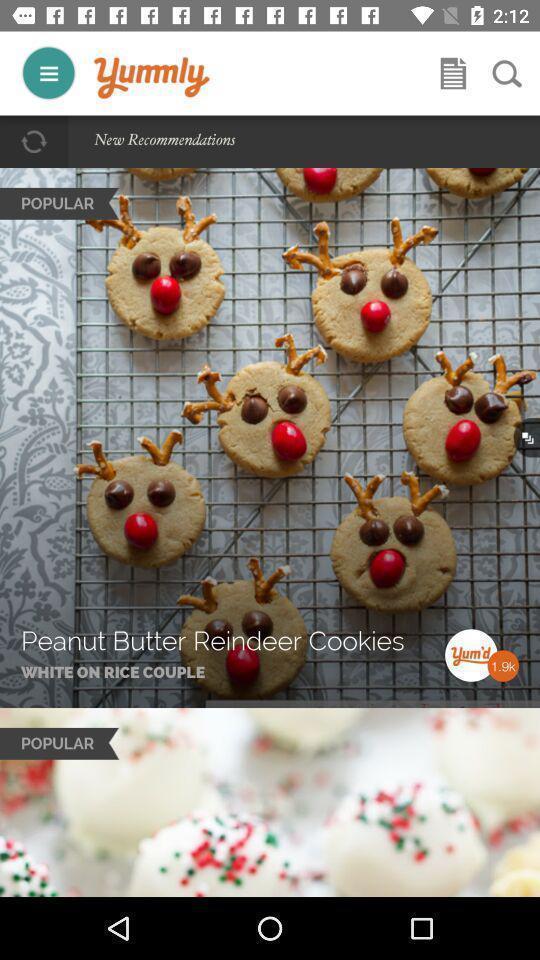Describe the content in this image. Screen displaying multiple food images in a recipe application. 